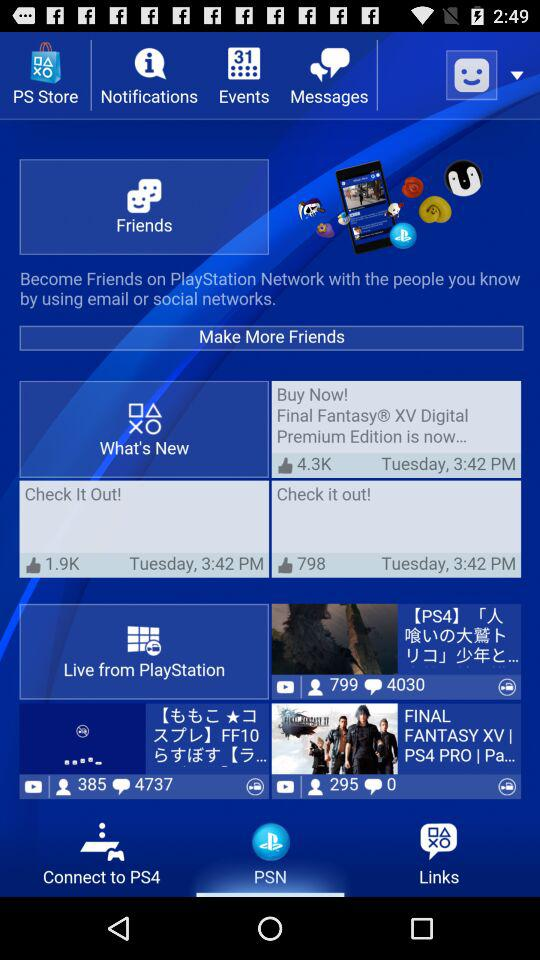How many people like "Final Fantasy? Final Fantasy is liked by 4.3K people. 